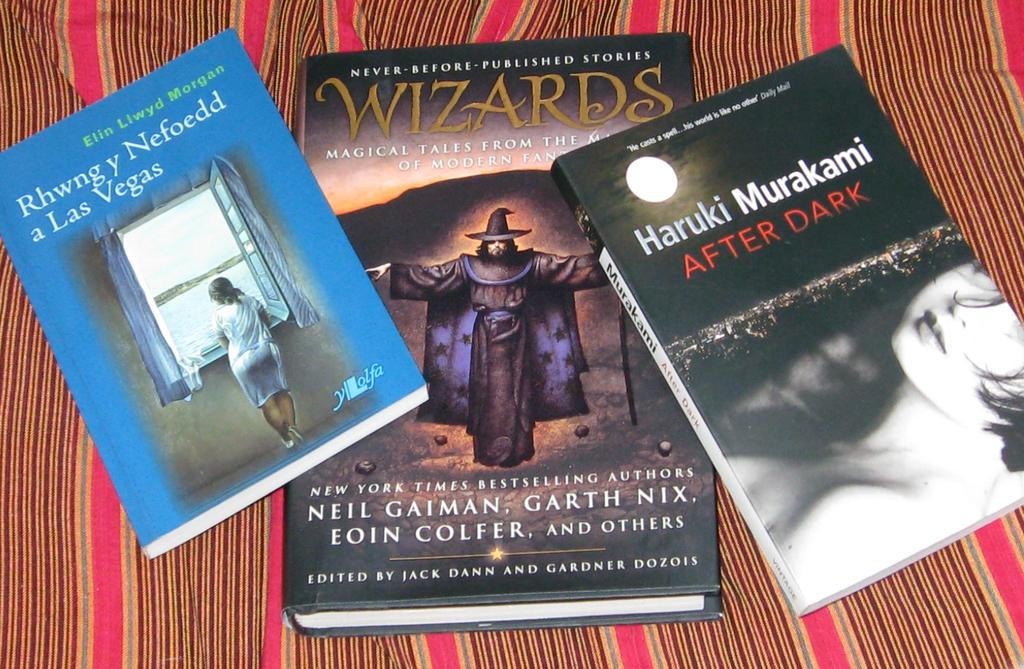<image>
Give a short and clear explanation of the subsequent image. three books next to one another with the title 'wizards' on the middle one 